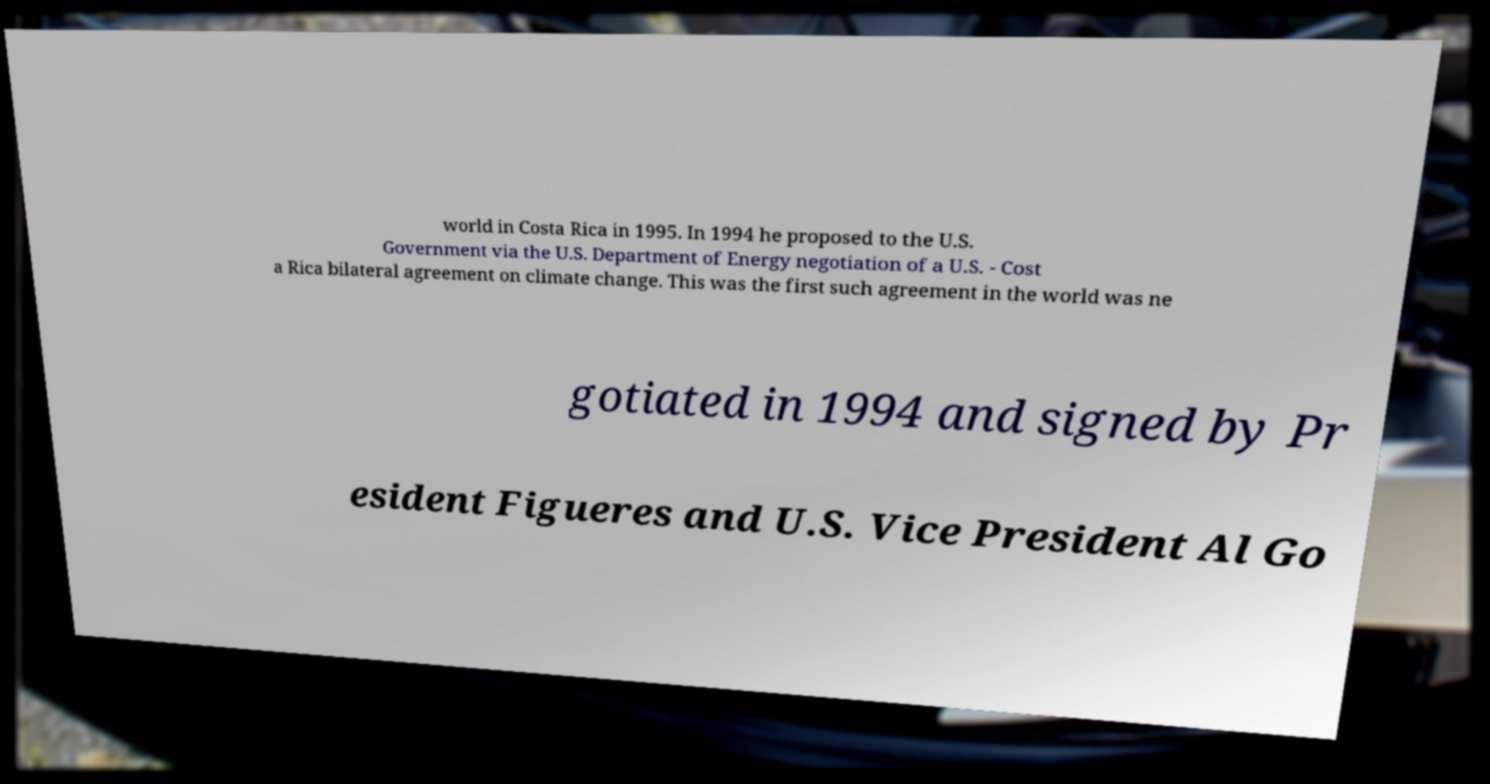There's text embedded in this image that I need extracted. Can you transcribe it verbatim? world in Costa Rica in 1995. In 1994 he proposed to the U.S. Government via the U.S. Department of Energy negotiation of a U.S. - Cost a Rica bilateral agreement on climate change. This was the first such agreement in the world was ne gotiated in 1994 and signed by Pr esident Figueres and U.S. Vice President Al Go 